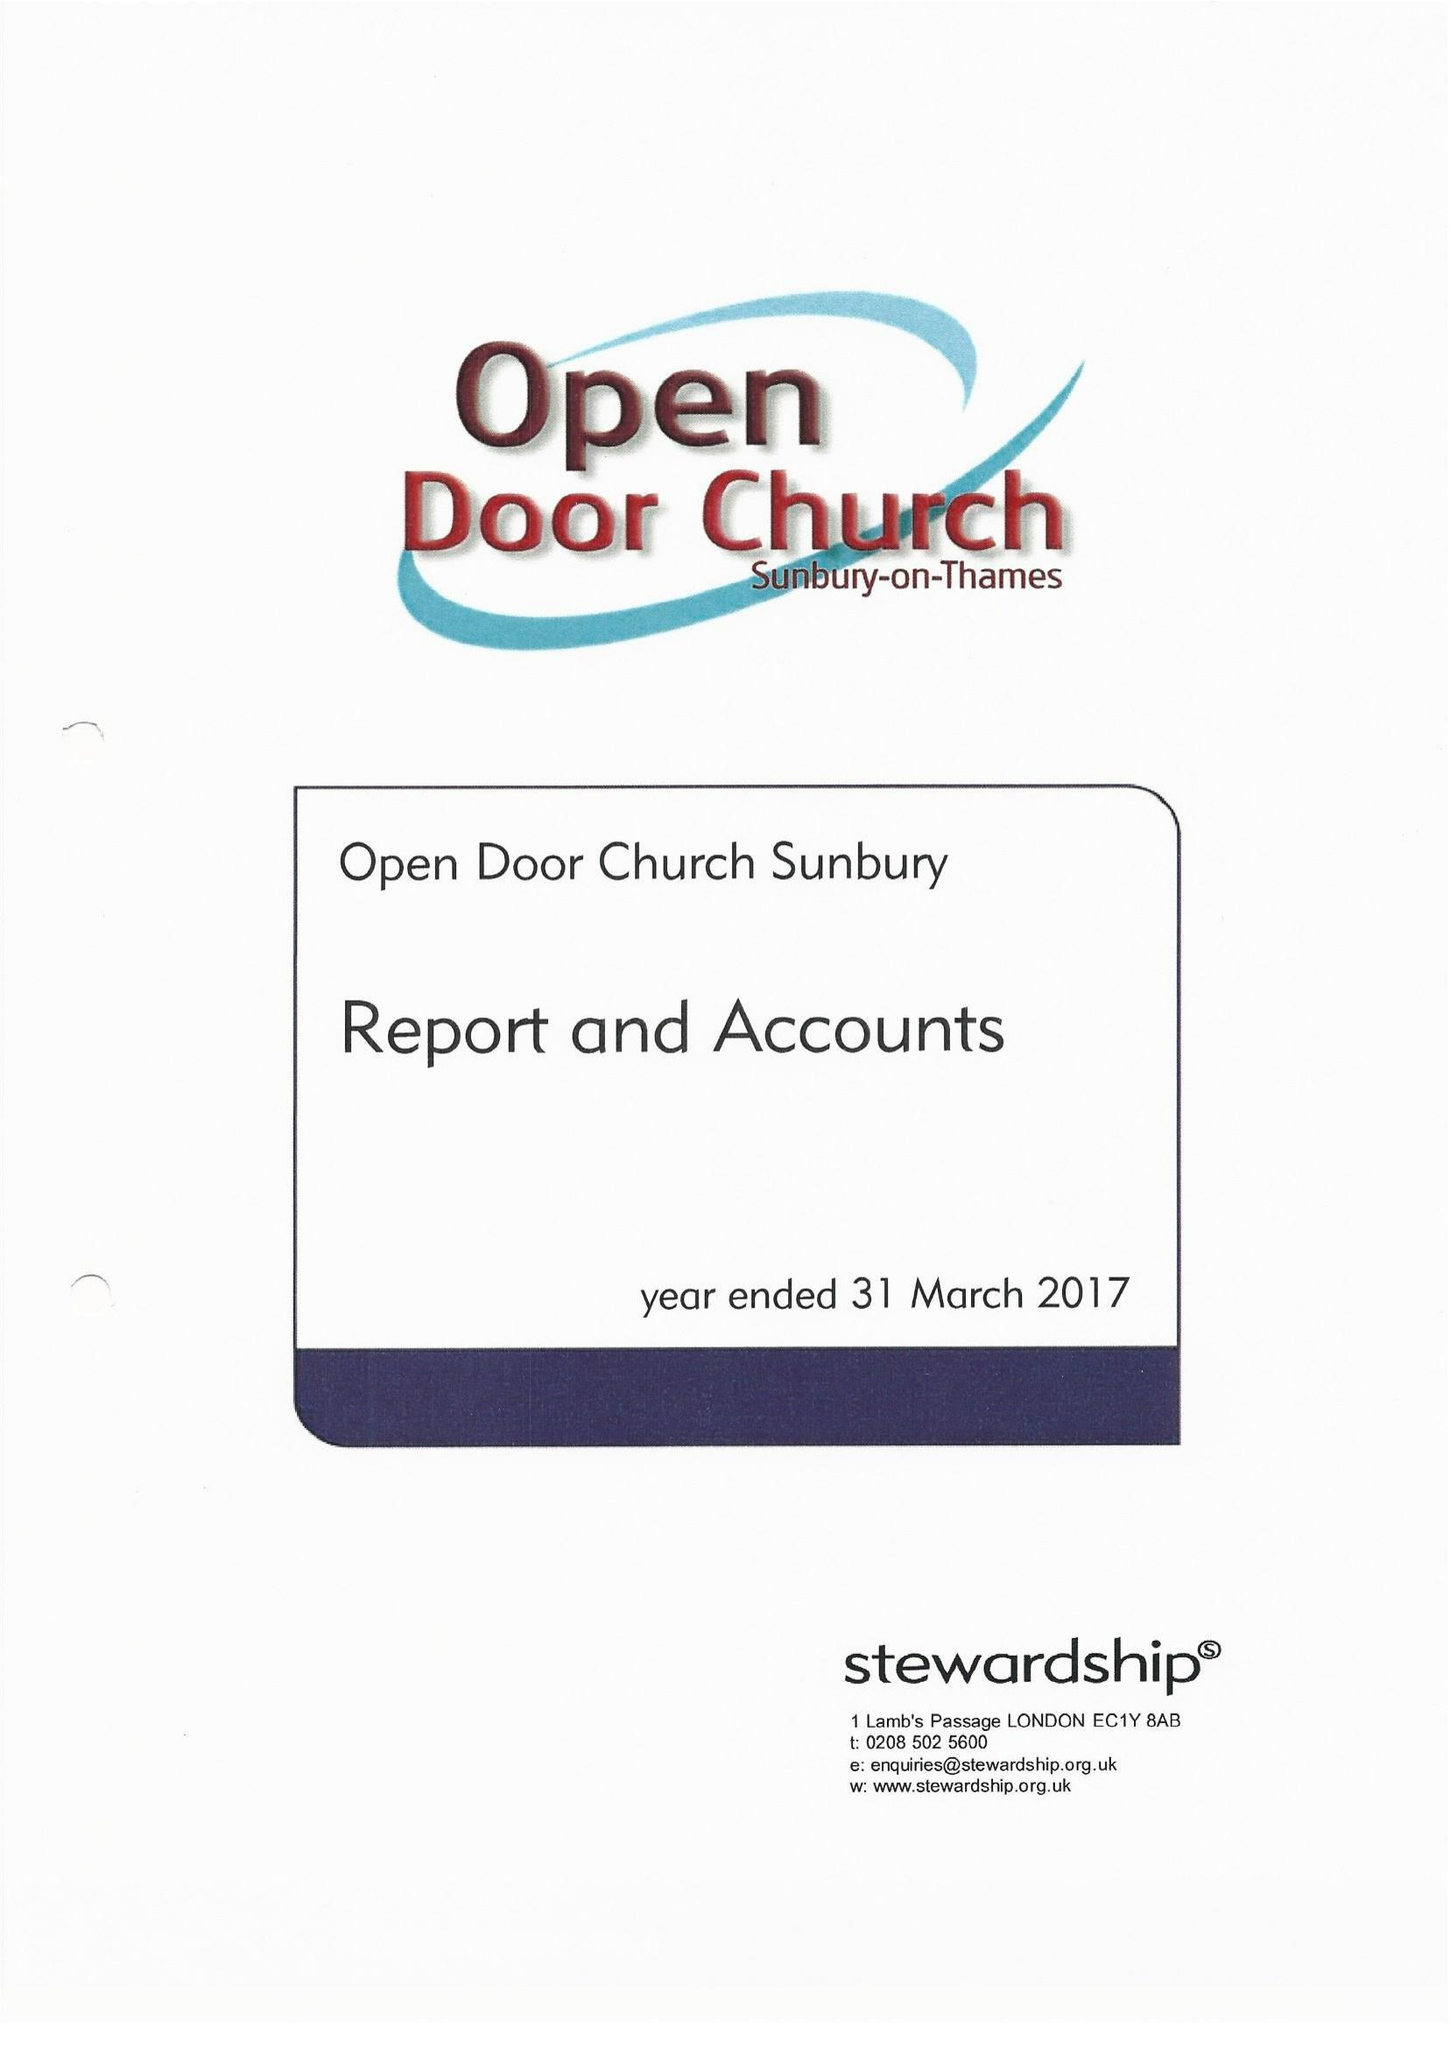What is the value for the address__street_line?
Answer the question using a single word or phrase. GREEN STREET 